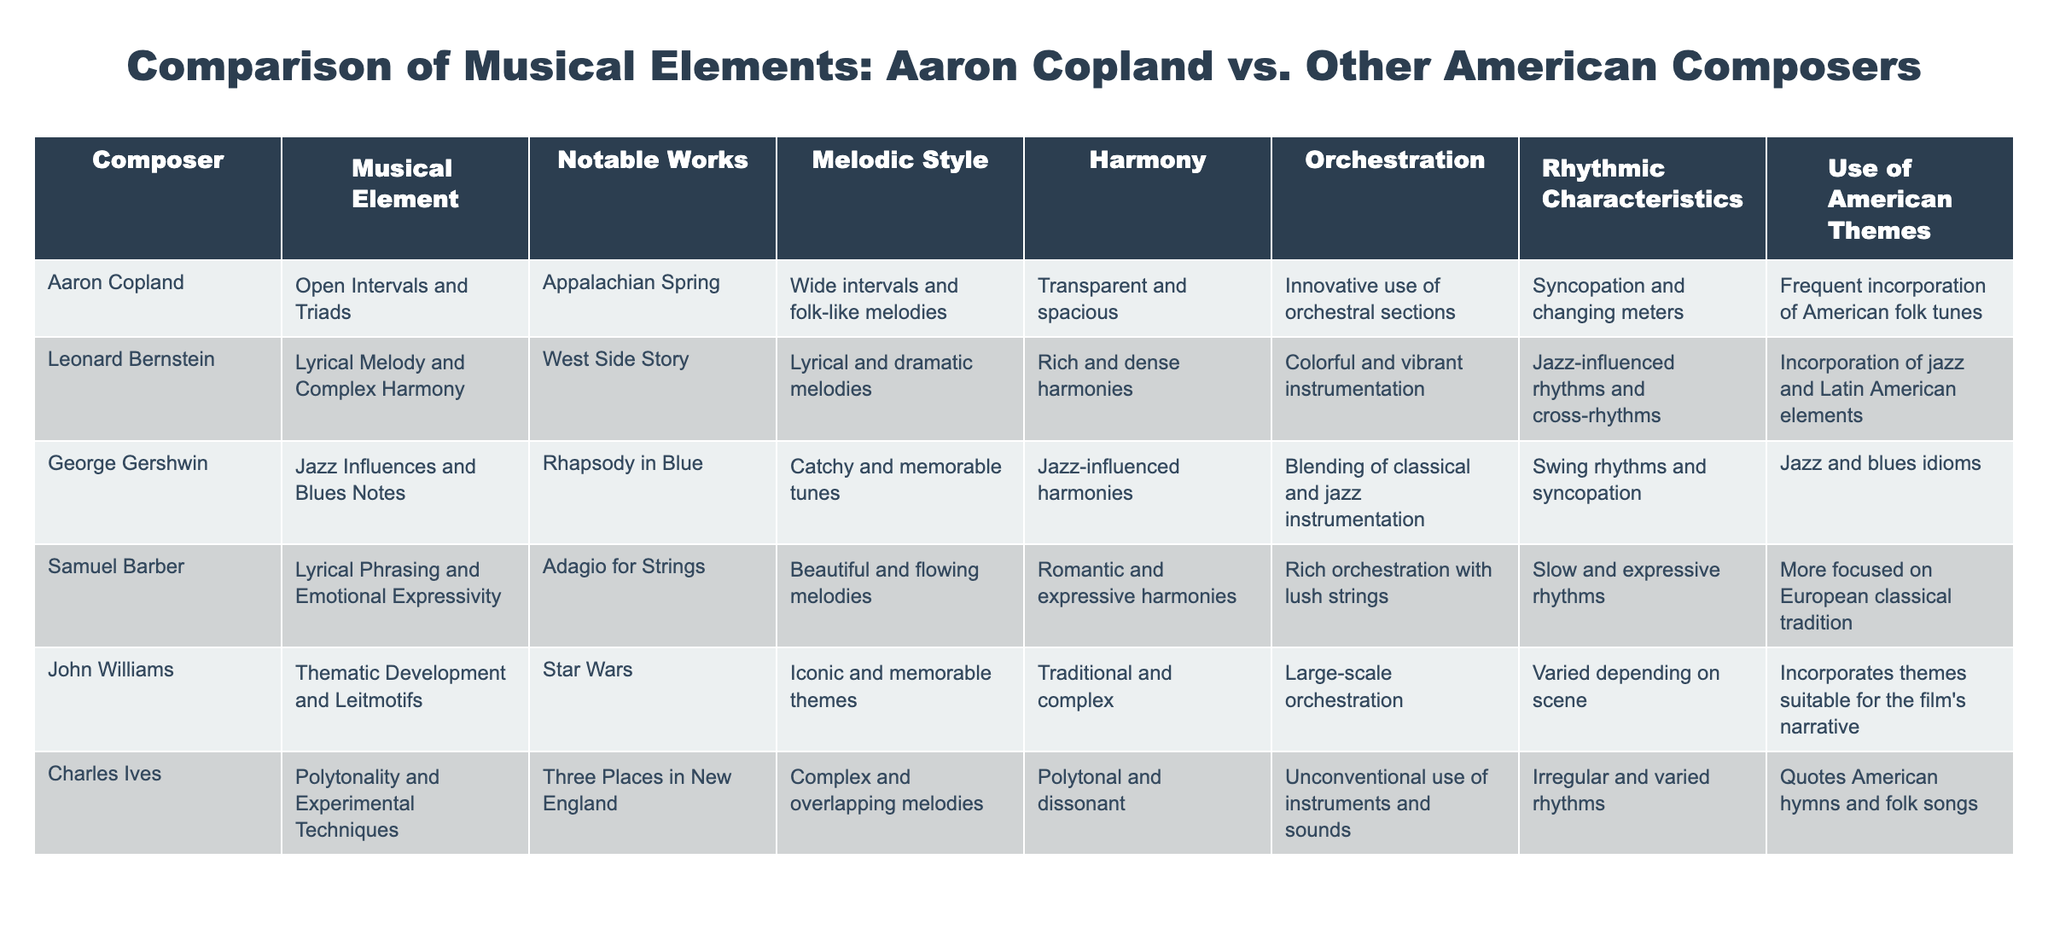What musical element is most prominent in Aaron Copland's works? The table shows that Copland is characterized by open intervals and triads. This is listed directly in the "Musical Element" column under his name.
Answer: Open intervals and triads Which composer has a notable work titled "Rhapsody in Blue"? According to the table, "Rhapsody in Blue" is attributed to George Gershwin, as indicated in the "Notable Works" column next to his name.
Answer: George Gershwin Do Leonard Bernstein's compositions incorporate jazz elements? The table indicates that Bernstein's works include jazz influences; this can be inferred from his listed rhythmic characteristics, which mention jazz-influenced rhythms.
Answer: Yes What is the predominant orchestration style of Samuel Barber? Samuel Barber is noted for rich orchestration with lush strings. This detail can be found in the "Orchestration" column corresponding to his name.
Answer: Rich orchestration with lush strings Which two composers frequently incorporate American folk themes into their music? By examining the "Use of American Themes" column, both Aaron Copland and Charles Ives are indicated to frequently incorporate American folk tunes and hymns, respectively.
Answer: Aaron Copland and Charles Ives How many composers listed have a lyrical melodic style? The table lists Leonard Bernstein and Samuel Barber as having a lyrical melodic style. There are two such composers when counting them.
Answer: 2 Is there a composer with a combination of complex harmony and lyrical melody? The table shows that Leonard Bernstein is noted for both lyrical melody and complex harmony, confirming that such a combination exists in this dataset.
Answer: Yes Which composer has the most experimental techniques in their music? Referring to the "Musical Element" column, Charles Ives is noted for polytonality and experimental techniques, making him the most experimental among the listed composers.
Answer: Charles Ives What melodic style is associated with John Williams' compositions? The table indicates that John Williams is known for iconic and memorable themes, which are specified in the "Melodic Style" column next to his name.
Answer: Iconic and memorable themes 